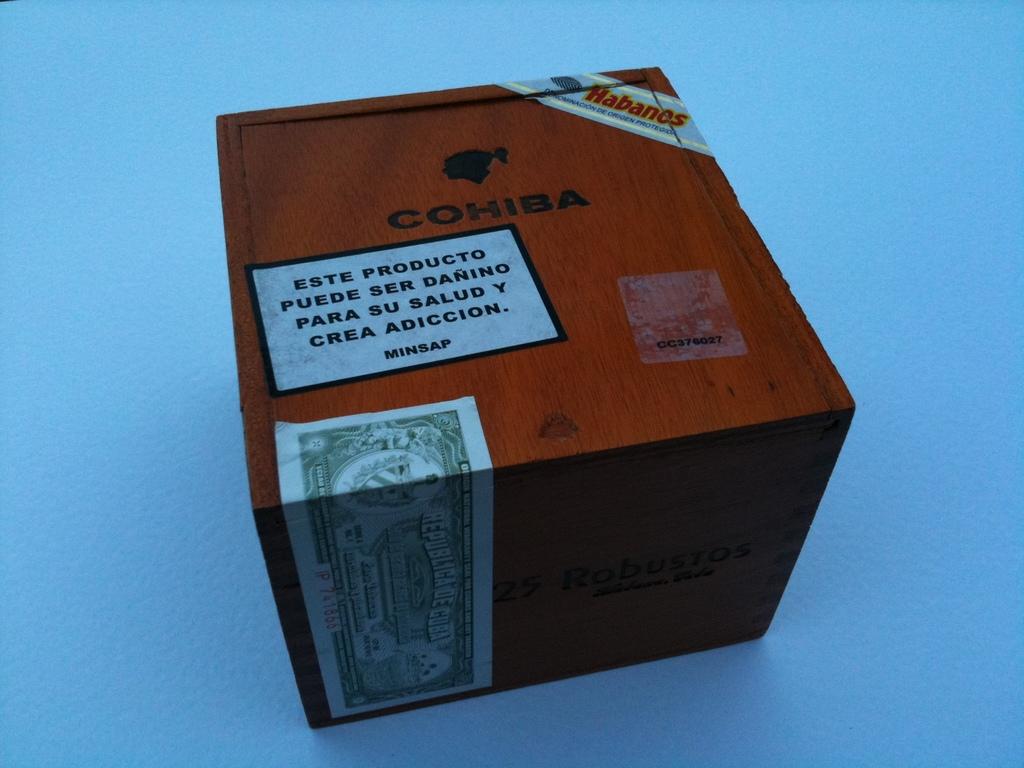What brand are these?
Ensure brevity in your answer.  Cohiba. 